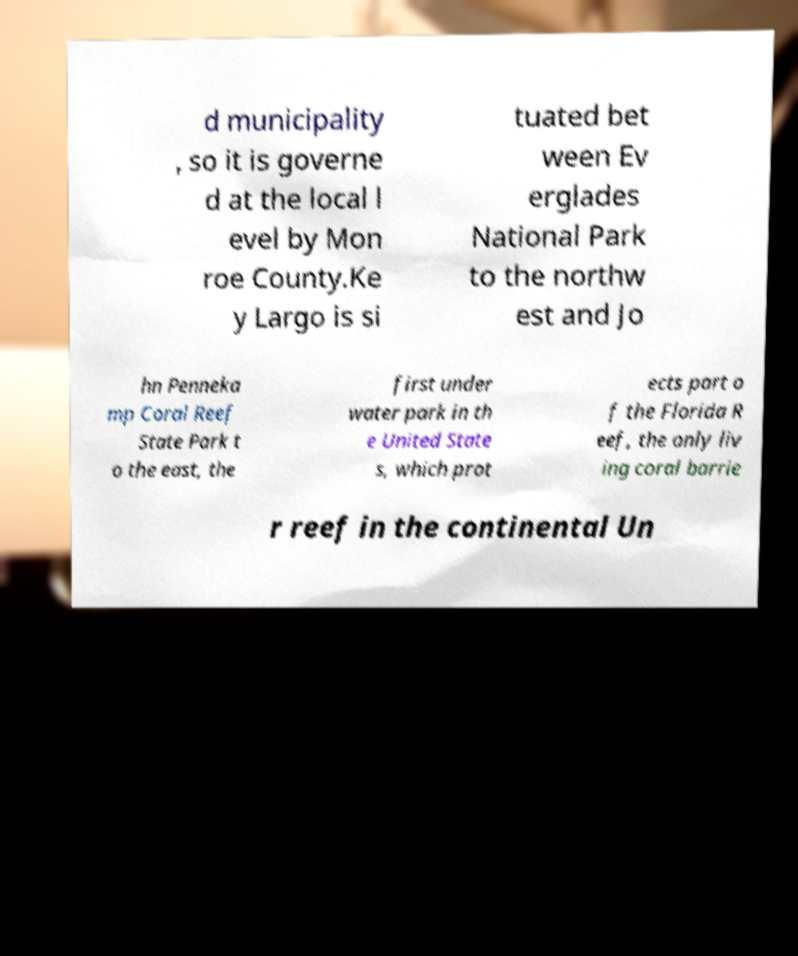There's text embedded in this image that I need extracted. Can you transcribe it verbatim? d municipality , so it is governe d at the local l evel by Mon roe County.Ke y Largo is si tuated bet ween Ev erglades National Park to the northw est and Jo hn Penneka mp Coral Reef State Park t o the east, the first under water park in th e United State s, which prot ects part o f the Florida R eef, the only liv ing coral barrie r reef in the continental Un 